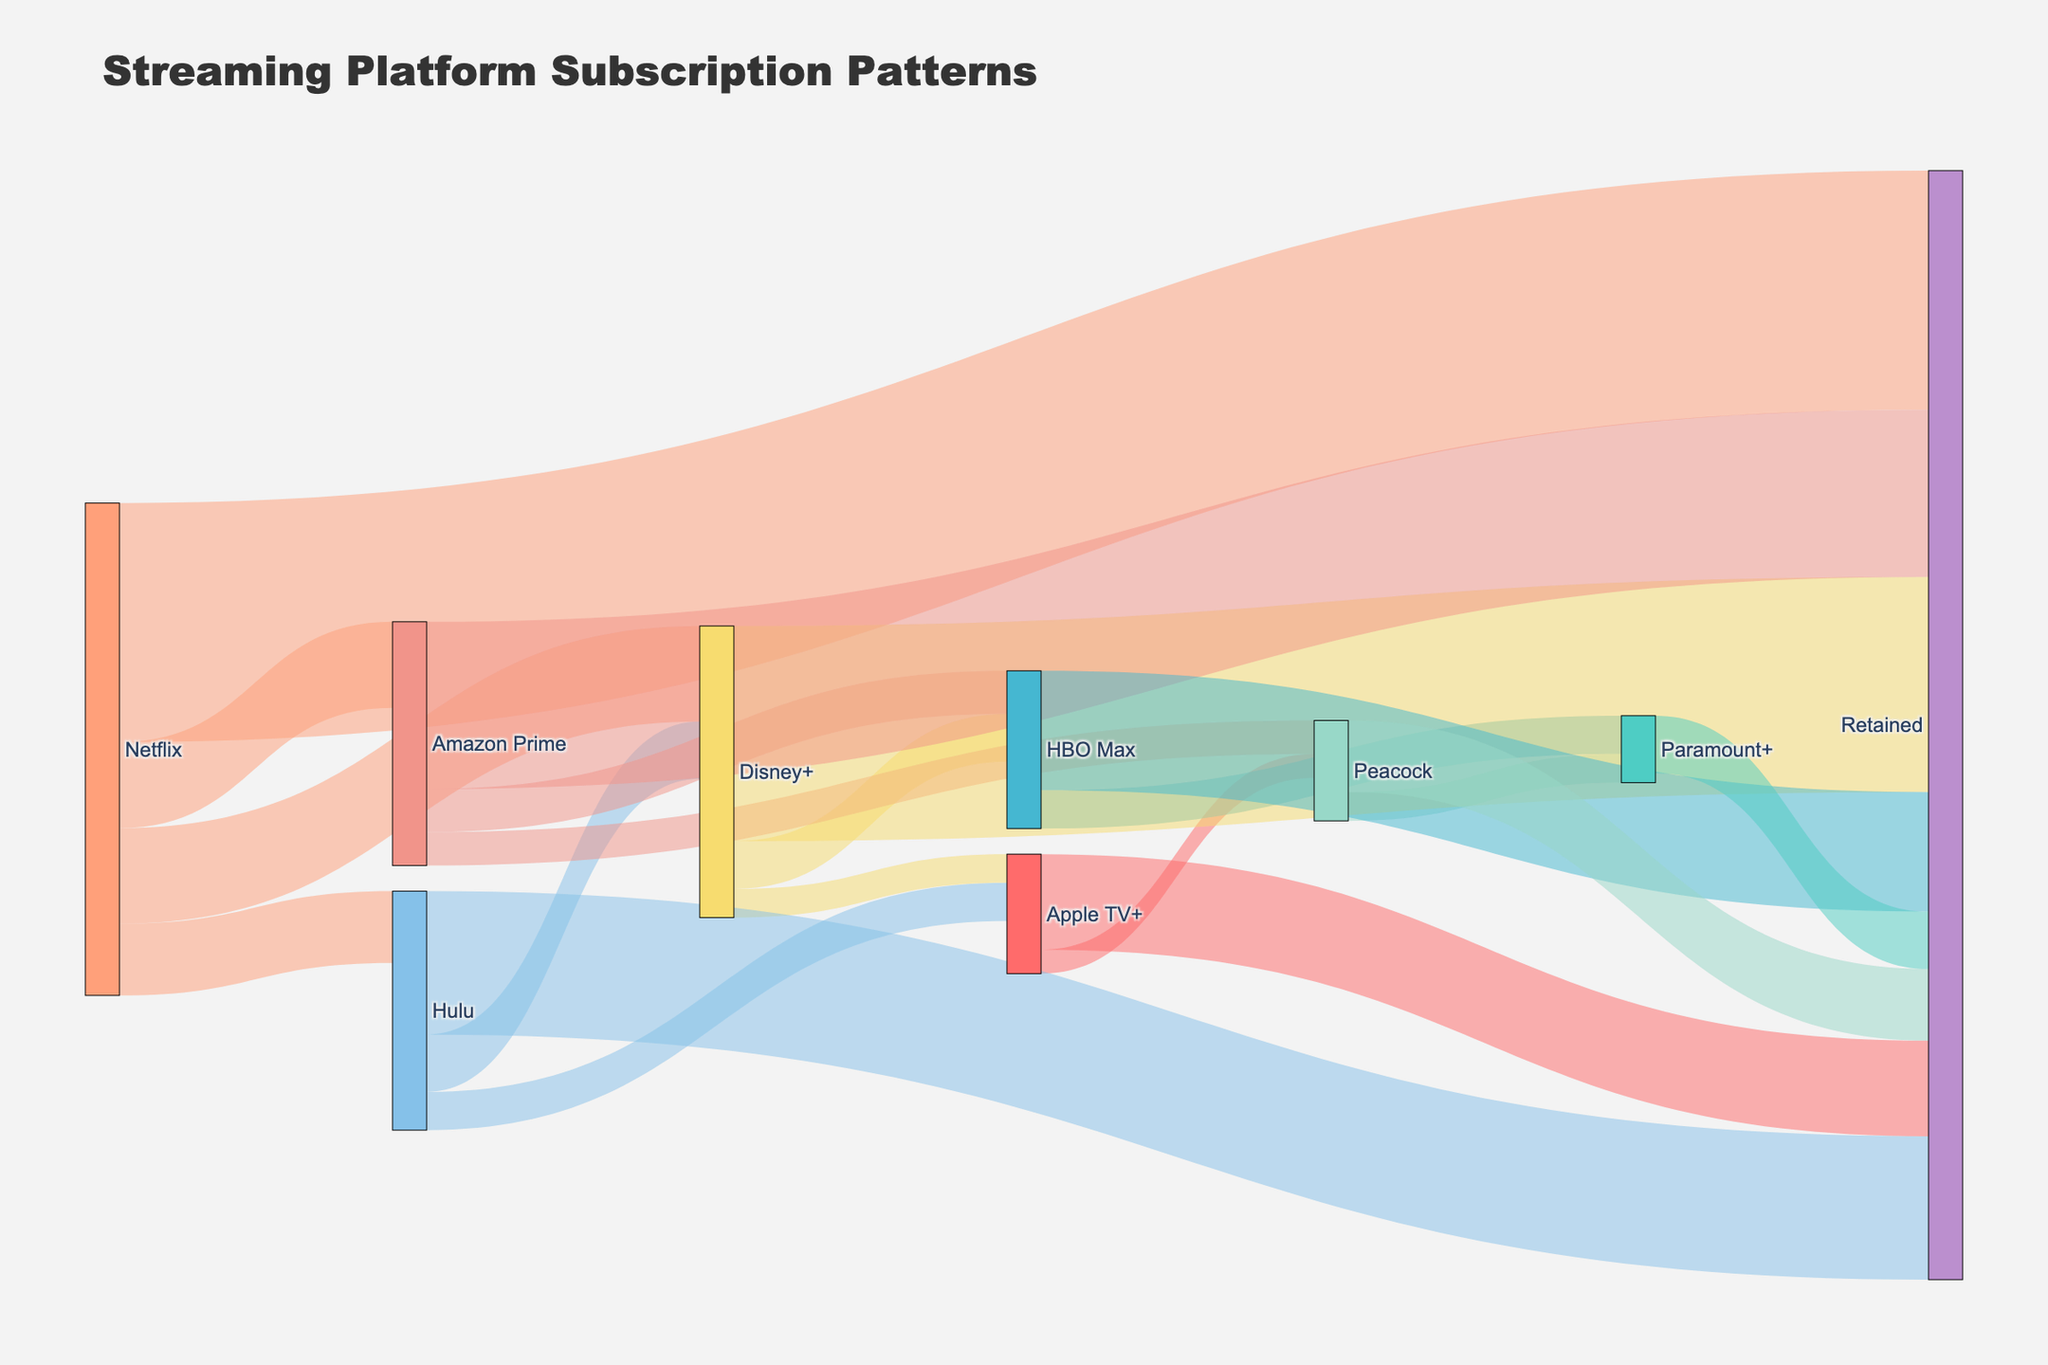What's the title of the figure? The title is typically displayed at the top center of the figure. In this case, it reads "Streaming Platform Subscription Patterns"
Answer: Streaming Platform Subscription Patterns Which streaming platform has the highest retention rate? By looking at the nodes with the "Retained" label, compare the values originating from each platform. Netflix has the highest value (5000) pointing to "Retained".
Answer: Netflix How many users migrated from Disney+ to HBO Max? Locate the link between Disney+ and HBO Max and read the value associated with it.
Answer: 1000 What is the total number of users retained across all platforms? To get the total number of users retained, sum all values leading to "Retained". 5000 (Netflix) + 3000 (Hulu) + 4500 (Disney+) + 3500 (Amazon Prime) + 2000 (Apple TV+) + 2500 (HBO Max) + 1500 (Peacock) + 1200 (Paramount+) = 23200
Answer: 23200 Which platform has the most users migrating to Hulu? Check the sources pointing to Hulu and compare their values: Netflix (1500). Only Netflix contributes to this migration.
Answer: Netflix What's the average number of users retained per platform? Divide the total number of users retained (23200) by the number of platforms retaining users (8). 23200 / 8 = 2900
Answer: 2900 Which platform received the fewest users from other platforms? Compare the values of the incoming links to each platform. Peacock has the lowest value of incoming users (700 + 500 = 1200)
Answer: Peacock What's the difference in the number of users migrating from Netflix to Hulu and from Netflix to Amazon Prime? Find and subtract the values: 1800 (Netflix to Amazon Prime) - 1500 (Netflix to Hulu) = 300
Answer: 300 Which platforms received migrating users from Amazon Prime? Identify the targets connected from Amazon Prime. These are HBO Max (900) and Peacock (700).
Answer: HBO Max, Peacock 